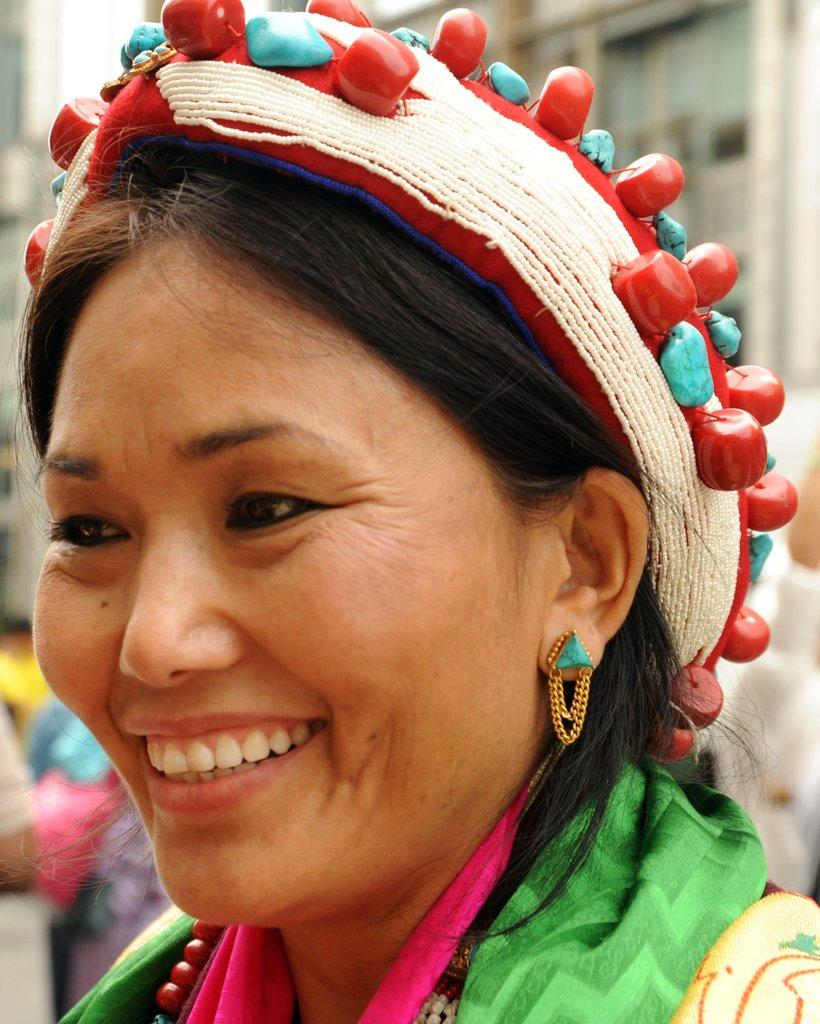What is present in the image? There is a person in the image. Can you describe the person's attire? The person is wearing a cap. What detail can be observed about the cap? The cap has beads on it. How many apples are on the person's mind in the image? There are no apples present in the image, and the person's thoughts or mental state cannot be determined from the image. 